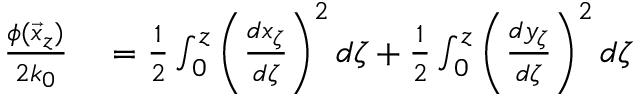<formula> <loc_0><loc_0><loc_500><loc_500>\begin{array} { r l } { \frac { \phi ( \vec { x } _ { z } ) } { 2 k _ { 0 } } } & = \frac { 1 } { 2 } \int _ { 0 } ^ { z } \left ( \frac { d x _ { \zeta } } { d \zeta } \right ) ^ { 2 } d \zeta + \frac { 1 } { 2 } \int _ { 0 } ^ { z } \left ( \frac { d y _ { \zeta } } { d \zeta } \right ) ^ { 2 } d \zeta } \end{array}</formula> 